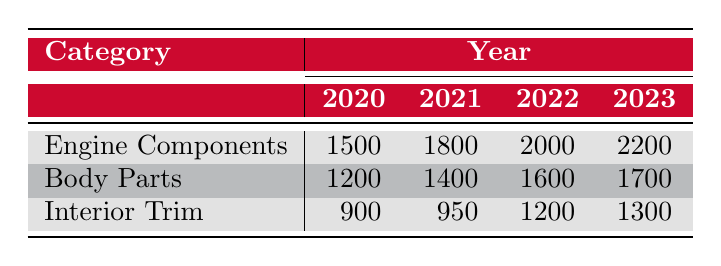What were the sales of Engine Components in 2021? The table shows that the sales for Engine Components in 2021 are listed directly underneath the category and year, which indicates that the sales figure is 1800.
Answer: 1800 What is the sales figure for Body Parts in 2022? By looking at the row for Body Parts and the column for 2022 in the table, the sales figure is marked as 1600.
Answer: 1600 Which category had the highest sales in 2023? In 2023, the sales figures for each category are listed as follows: Engine Components (2200), Body Parts (1700), and Interior Trim (1300). Since 2200 is the highest among these numbers, Engine Components had the highest sales in 2023.
Answer: Engine Components How much did sales of Interior Trim increase from 2020 to 2023? First, the sales for Interior Trim in 2020 is 900, and in 2023 it is 1300. To find the increase, subtract 900 from 1300, which gives us 400. Thus, the sales increased by 400 from 2020 to 2023.
Answer: 400 Did the sales of Body Parts decrease in any year from 2020 to 2023? Looking at the sales figures for Body Parts: 1200 in 2020, 1400 in 2021, 1600 in 2022, and 1700 in 2023. Since all values are increasing, Body Parts did not see a decrease in any year.
Answer: No What is the total sales of Engine Components across all years? The sales of Engine Components per year are: 1500 (2020), 1800 (2021), 2000 (2022), and 2200 (2023). To find the total, we add these figures: 1500 + 1800 + 2000 + 2200 = 7500.
Answer: 7500 Which year had the lowest sales for Interior Trim? The sales figures for Interior Trim are: 900 in 2020, 950 in 2021, 1200 in 2022, and 1300 in 2023. The lowest figure is 900 in 2020.
Answer: 2020 What is the average sales of Body Parts from 2020 to 2023? The sales figures for Body Parts are 1200 (2020), 1400 (2021), 1600 (2022), and 1700 (2023). To calculate the average, we add these values to get 1200 + 1400 + 1600 + 1700 = 5900 and divide by 4 (the number of years), resulting in an average of 1475.
Answer: 1475 If the sales of Engine Components continue to increase at the same rate seen from 2022 to 2023, what would the projected sales for 2024 be? Observing the sales for Engine Components from 2022 to 2023, it increases from 2000 to 2200, giving a difference of 200. Assuming the same increase for 2024, we add 200 to the 2023 figure of 2200, resulting in a projection of 2400 for 2024.
Answer: 2400 